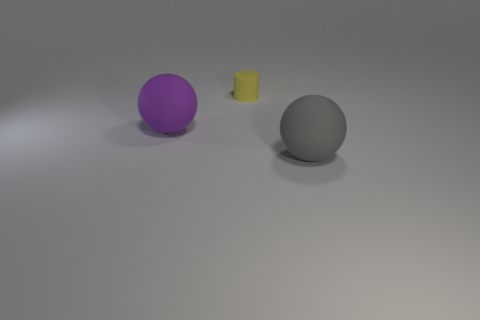What number of cylinders are either small objects or purple matte things?
Provide a succinct answer. 1. There is a big ball to the left of the tiny yellow thing; what is its color?
Provide a short and direct response. Purple. What shape is the other object that is the same size as the purple matte object?
Make the answer very short. Sphere. How many yellow matte things are in front of the yellow rubber cylinder?
Offer a terse response. 0. How many things are big purple balls or big green matte blocks?
Offer a terse response. 1. There is a thing that is on the right side of the purple ball and in front of the small yellow cylinder; what shape is it?
Offer a very short reply. Sphere. How many rubber spheres are there?
Give a very brief answer. 2. What is the color of the cylinder that is made of the same material as the large purple ball?
Give a very brief answer. Yellow. Is the number of small cylinders greater than the number of blue matte things?
Your response must be concise. Yes. There is a rubber object that is both left of the gray ball and in front of the yellow rubber object; what size is it?
Give a very brief answer. Large. 